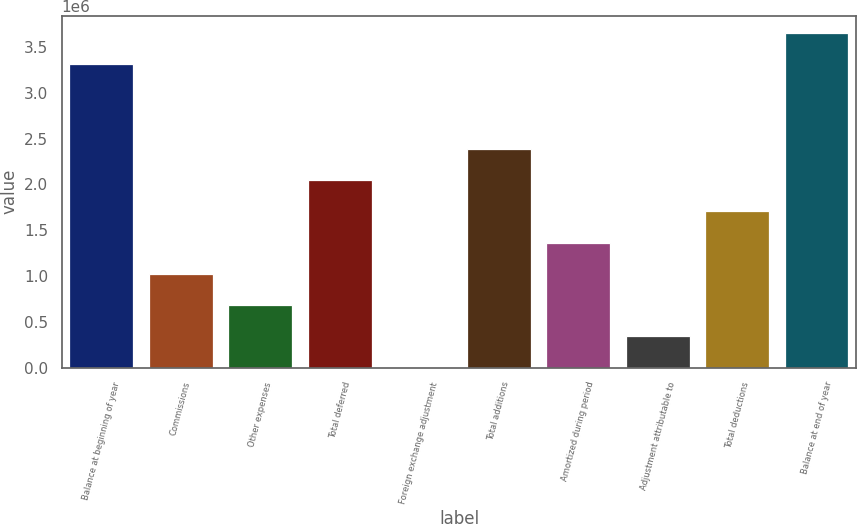Convert chart. <chart><loc_0><loc_0><loc_500><loc_500><bar_chart><fcel>Balance at beginning of year<fcel>Commissions<fcel>Other expenses<fcel>Total deferred<fcel>Foreign exchange adjustment<fcel>Total additions<fcel>Amortized during period<fcel>Adjustment attributable to<fcel>Total deductions<fcel>Balance at end of year<nl><fcel>3.3195e+06<fcel>1.02544e+06<fcel>685311<fcel>2.04582e+06<fcel>5055<fcel>2.38595e+06<fcel>1.36557e+06<fcel>345183<fcel>1.7057e+06<fcel>3.65963e+06<nl></chart> 